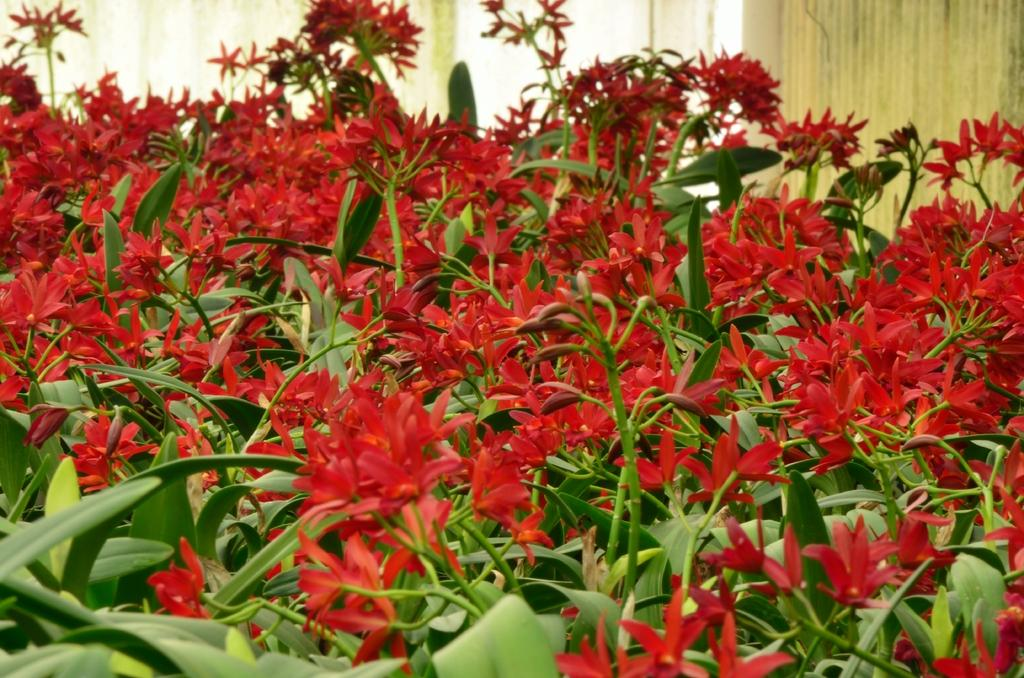What type of plants can be seen in the image? There are plants with red flowers in the image. What is visible in the background of the image? There is a wall in the background of the image. Can you describe the river flowing through the image? There is no river present in the image; it features plants with red flowers and a wall in the background. 